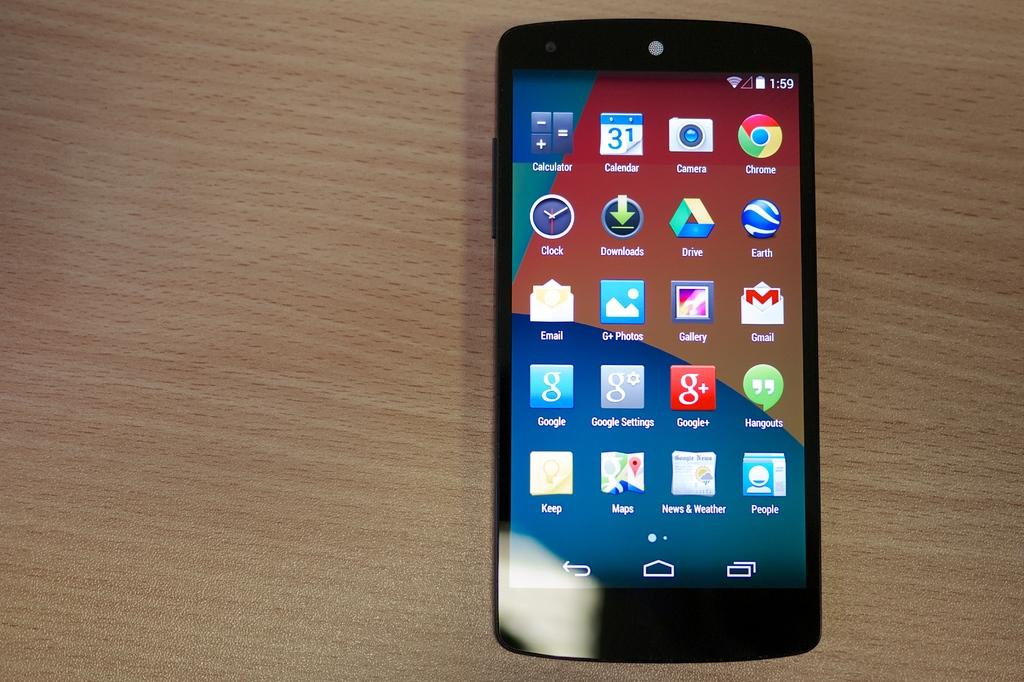<image>
Present a compact description of the photo's key features. Phone screen which has the first app as the Calculator. 